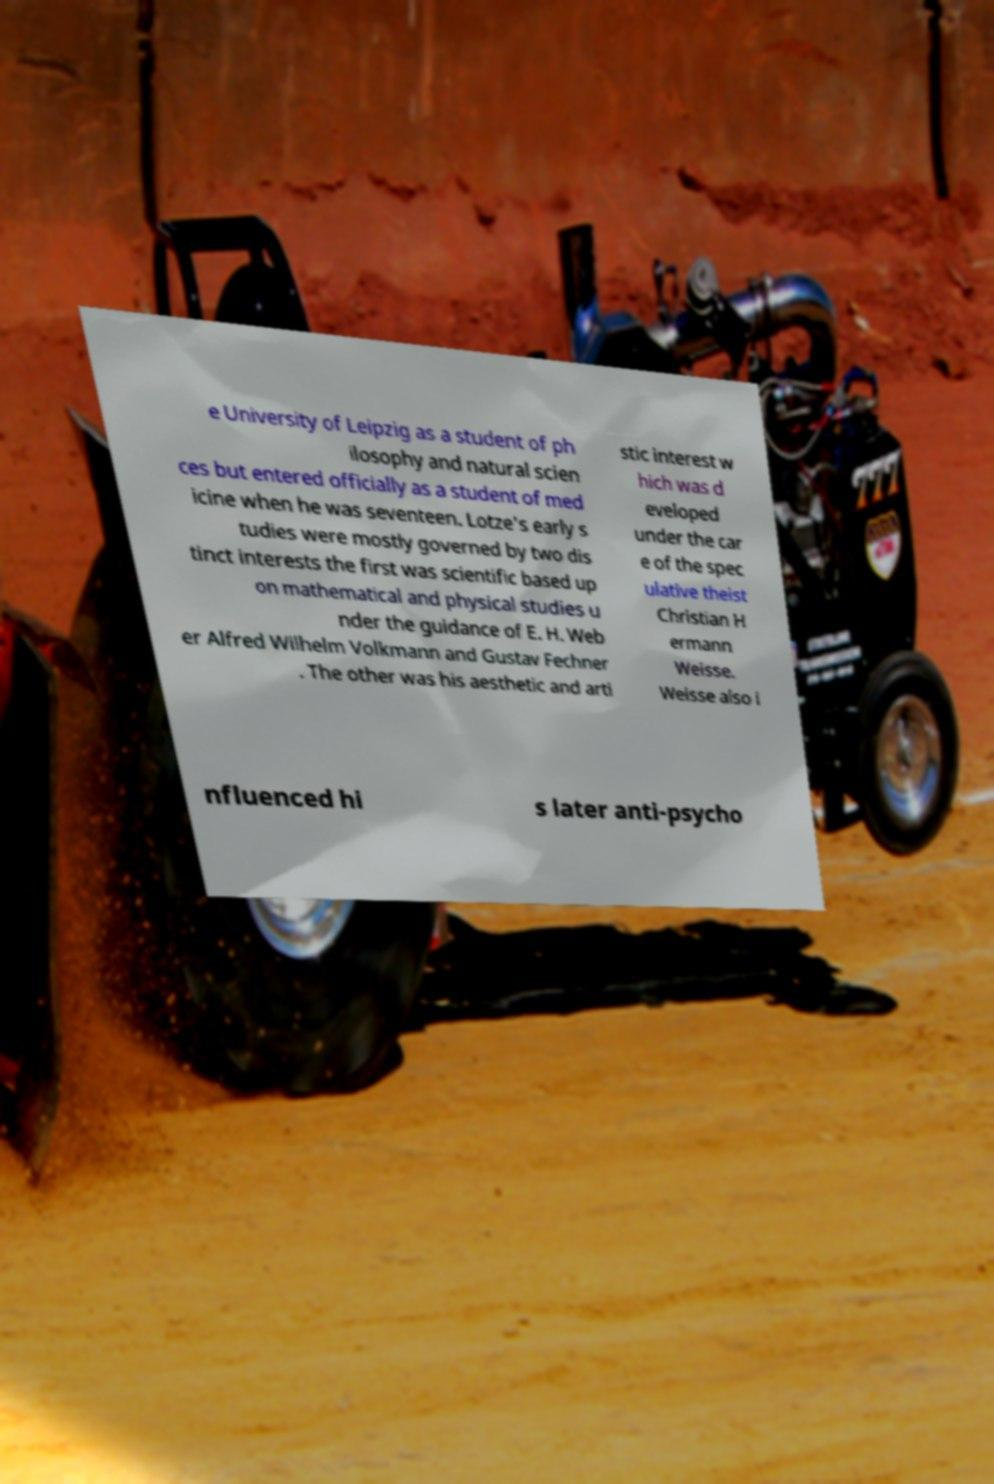For documentation purposes, I need the text within this image transcribed. Could you provide that? e University of Leipzig as a student of ph ilosophy and natural scien ces but entered officially as a student of med icine when he was seventeen. Lotze's early s tudies were mostly governed by two dis tinct interests the first was scientific based up on mathematical and physical studies u nder the guidance of E. H. Web er Alfred Wilhelm Volkmann and Gustav Fechner . The other was his aesthetic and arti stic interest w hich was d eveloped under the car e of the spec ulative theist Christian H ermann Weisse. Weisse also i nfluenced hi s later anti-psycho 